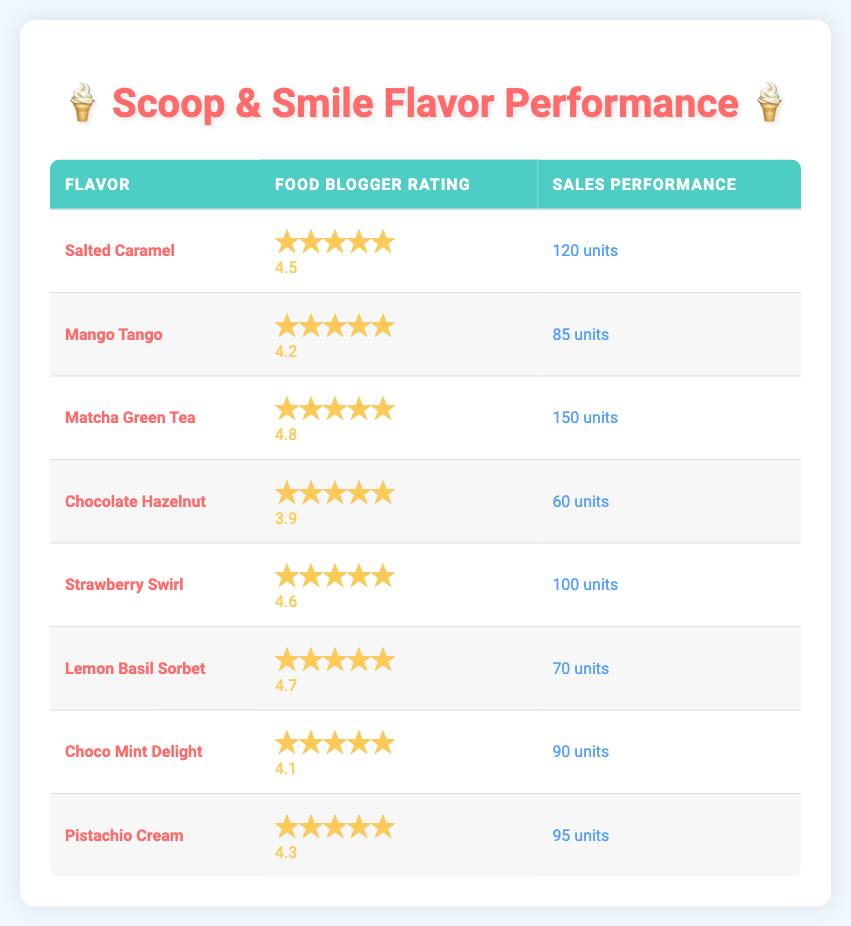What is the flavor with the highest food blogger rating? The flavor with the highest rating is Matcha Green Tea with a rating of 4.8.
Answer: Matcha Green Tea Which flavor has the lowest sales performance? The flavor with the lowest sales performance is Chocolate Hazelnut, which sold 60 units.
Answer: Chocolate Hazelnut Is it true that Strawberry Swirl has a higher sales performance than Pistachio Cream? Strawberry Swirl sold 100 units, while Pistachio Cream sold 95 units, which means Strawberry Swirl has a higher sales performance.
Answer: Yes What is the average food blogger rating of all flavors? Adding all ratings: 4.5 + 4.2 + 4.8 + 3.9 + 4.6 + 4.7 + 4.1 + 4.3 = 34.1. There are 8 entries, so the average is 34.1 / 8 = 4.2625, which rounds to 4.26.
Answer: 4.26 Which flavors have a food blogger rating equal to or greater than 4.5 and also a sales performance greater than 100 units? The flavors that meet both criteria are Salted Caramel (4.5, 120 units) and Matcha Green Tea (4.8, 150 units).
Answer: Salted Caramel and Matcha Green Tea What is the difference in sales performance between the highest and lowest performing flavors? Matcha Green Tea has the highest sales performance with 150 units, while Chocolate Hazelnut has the lowest with 60 units. The difference is 150 - 60 = 90 units.
Answer: 90 units How many flavors have a rating above 4.5? The flavors with ratings above 4.5 are: Salted Caramel (4.5), Matcha Green Tea (4.8), Strawberry Swirl (4.6), and Lemon Basil Sorbet (4.7). Therefore, there are 4 flavors.
Answer: 4 flavors Which flavor has a rating of 4.1 or lower? The only flavor with a rating of 4.1 or lower is Chocolate Hazelnut, which has a rating of 3.9.
Answer: Chocolate Hazelnut What is the total sales performance for flavors rated 4.2 and above? The flavors rated 4.2 and above are Salted Caramel (120 units), Mango Tango (85 units), Matcha Green Tea (150 units), Strawberry Swirl (100 units), Lemon Basil Sorbet (70 units), Choco Mint Delight (90 units), and Pistachio Cream (95 units). Totaling these gives 120 + 85 + 150 + 100 + 70 + 90 + 95 = 710 units.
Answer: 710 units 